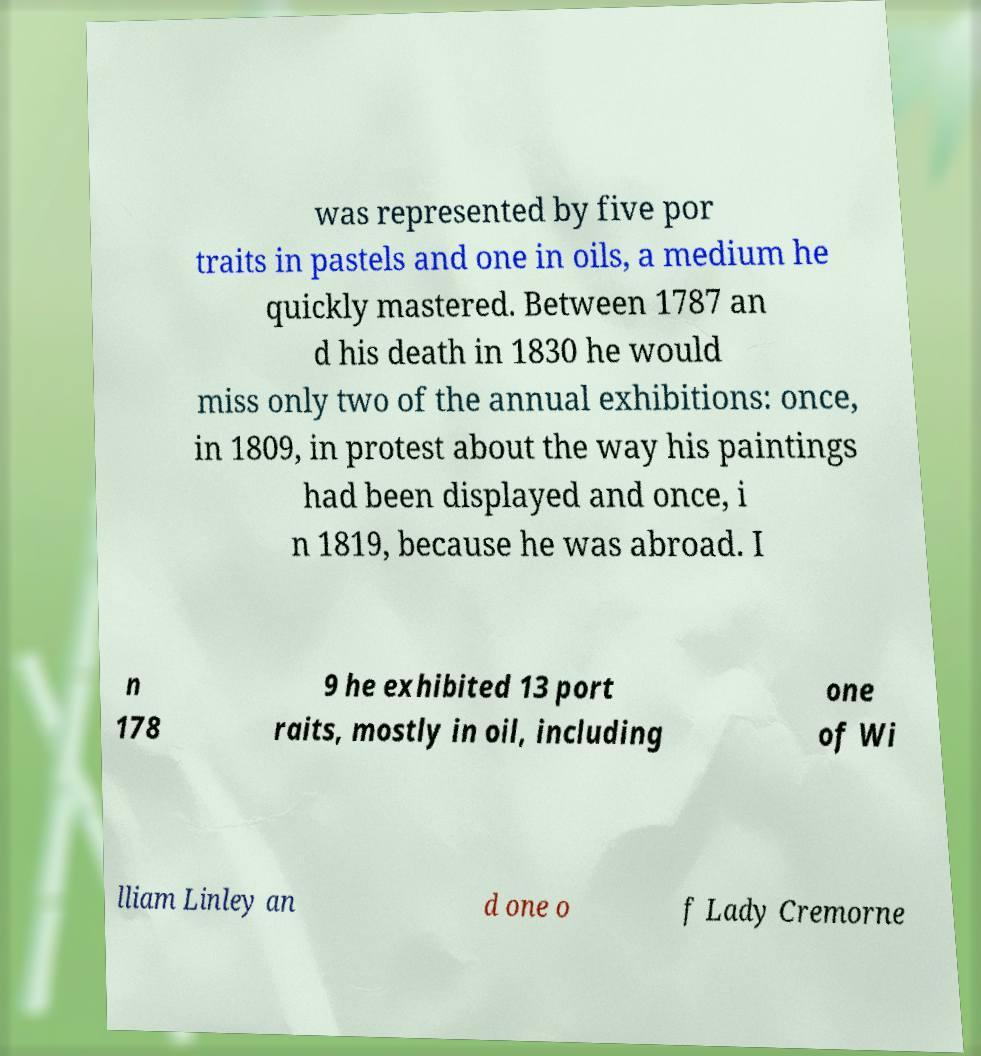Please read and relay the text visible in this image. What does it say? was represented by five por traits in pastels and one in oils, a medium he quickly mastered. Between 1787 an d his death in 1830 he would miss only two of the annual exhibitions: once, in 1809, in protest about the way his paintings had been displayed and once, i n 1819, because he was abroad. I n 178 9 he exhibited 13 port raits, mostly in oil, including one of Wi lliam Linley an d one o f Lady Cremorne 